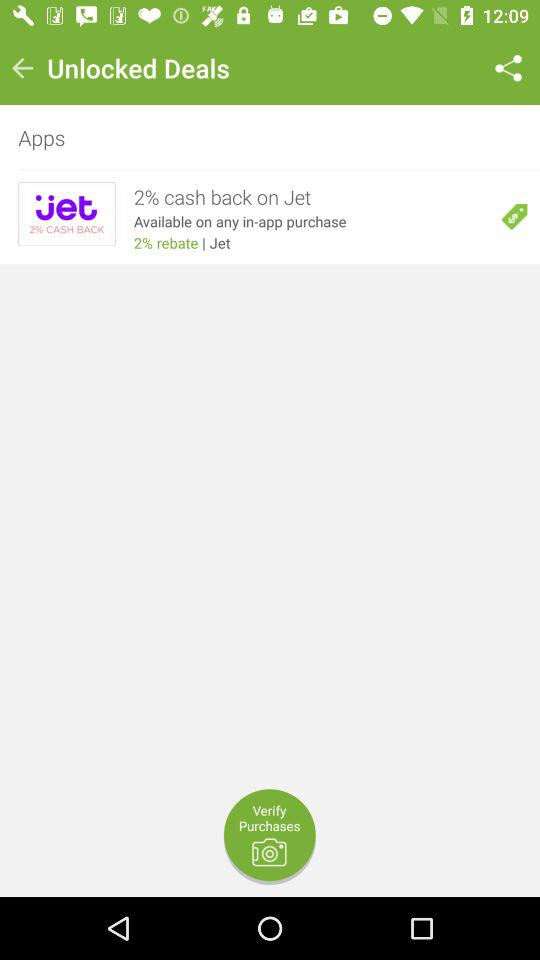How much cash back in percentage is available on "Jet"? The percentage of cash back is 2. 